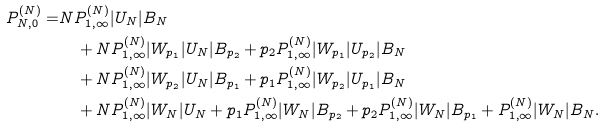Convert formula to latex. <formula><loc_0><loc_0><loc_500><loc_500>P _ { N , 0 } ^ { ( N ) } = & N P _ { 1 , \infty } ^ { ( N ) } | U _ { N } | B _ { N } \\ & \quad + N P _ { 1 , \infty } ^ { ( N ) } | W _ { p _ { 1 } } | U _ { N } | B _ { p _ { 2 } } + p _ { 2 } P _ { 1 , \infty } ^ { ( N ) } | W _ { p _ { 1 } } | U _ { p _ { 2 } } | B _ { N } \\ & \quad + N P _ { 1 , \infty } ^ { ( N ) } | W _ { p _ { 2 } } | U _ { N } | B _ { p _ { 1 } } + p _ { 1 } P _ { 1 , \infty } ^ { ( N ) } | W _ { p _ { 2 } } | U _ { p _ { 1 } } | B _ { N } \\ & \quad + N P _ { 1 , \infty } ^ { ( N ) } | W _ { N } | U _ { N } + p _ { 1 } P _ { 1 , \infty } ^ { ( N ) } | W _ { N } | B _ { p _ { 2 } } + p _ { 2 } P _ { 1 , \infty } ^ { ( N ) } | W _ { N } | B _ { p _ { 1 } } + P _ { 1 , \infty } ^ { ( N ) } | W _ { N } | B _ { N } .</formula> 